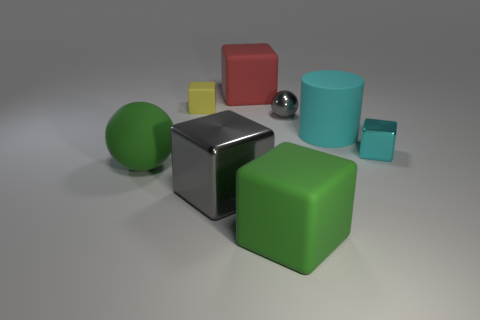What number of objects are red matte cubes or things that are behind the green cube?
Keep it short and to the point. 7. What size is the shiny object that is the same color as the cylinder?
Keep it short and to the point. Small. What shape is the tiny object that is in front of the small metallic sphere?
Make the answer very short. Cube. There is a tiny cube that is to the right of the red rubber object; is it the same color as the tiny rubber thing?
Ensure brevity in your answer.  No. There is a thing that is the same color as the large rubber cylinder; what material is it?
Keep it short and to the point. Metal. Does the cyan thing that is right of the cyan cylinder have the same size as the tiny metallic sphere?
Offer a very short reply. Yes. Is there a metallic ball that has the same color as the big shiny thing?
Provide a succinct answer. Yes. Is there a red cube in front of the green matte thing that is behind the large green block?
Provide a short and direct response. No. Are there any brown things made of the same material as the big gray cube?
Offer a terse response. No. The small block on the left side of the gray sphere that is on the left side of the cylinder is made of what material?
Provide a short and direct response. Rubber. 